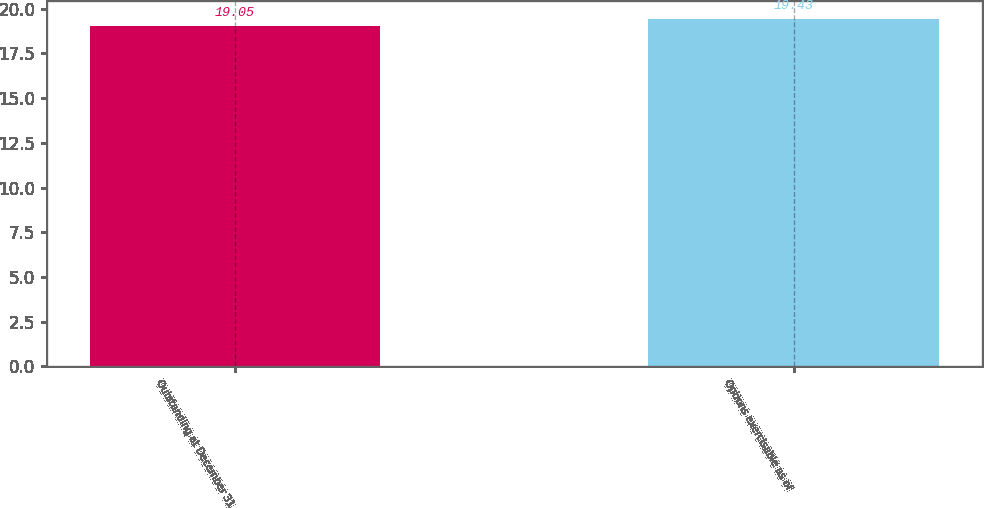Convert chart to OTSL. <chart><loc_0><loc_0><loc_500><loc_500><bar_chart><fcel>Outstanding at December 31<fcel>Options exercisable as of<nl><fcel>19.05<fcel>19.43<nl></chart> 